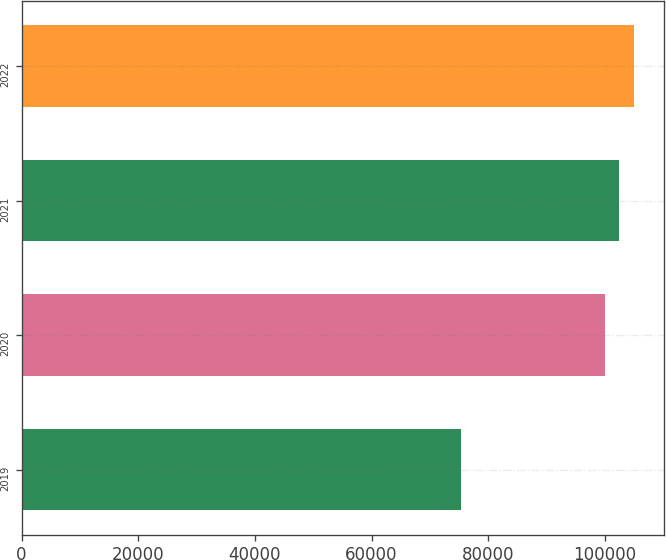Convert chart. <chart><loc_0><loc_0><loc_500><loc_500><bar_chart><fcel>2019<fcel>2020<fcel>2021<fcel>2022<nl><fcel>75342<fcel>100000<fcel>102466<fcel>104932<nl></chart> 